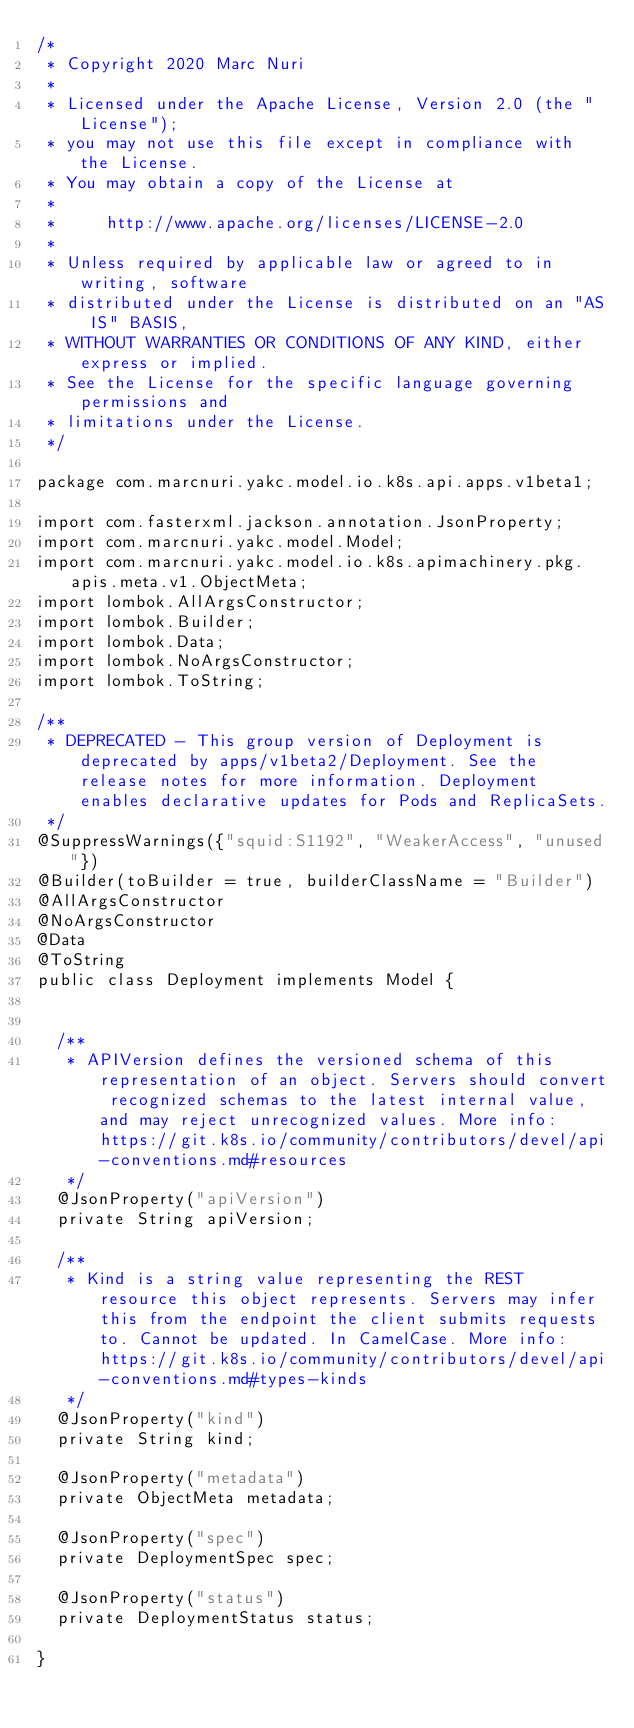Convert code to text. <code><loc_0><loc_0><loc_500><loc_500><_Java_>/*
 * Copyright 2020 Marc Nuri
 *
 * Licensed under the Apache License, Version 2.0 (the "License");
 * you may not use this file except in compliance with the License.
 * You may obtain a copy of the License at
 *
 *     http://www.apache.org/licenses/LICENSE-2.0
 *
 * Unless required by applicable law or agreed to in writing, software
 * distributed under the License is distributed on an "AS IS" BASIS,
 * WITHOUT WARRANTIES OR CONDITIONS OF ANY KIND, either express or implied.
 * See the License for the specific language governing permissions and
 * limitations under the License.
 */

package com.marcnuri.yakc.model.io.k8s.api.apps.v1beta1;

import com.fasterxml.jackson.annotation.JsonProperty;
import com.marcnuri.yakc.model.Model;
import com.marcnuri.yakc.model.io.k8s.apimachinery.pkg.apis.meta.v1.ObjectMeta;
import lombok.AllArgsConstructor;
import lombok.Builder;
import lombok.Data;
import lombok.NoArgsConstructor;
import lombok.ToString;

/**
 * DEPRECATED - This group version of Deployment is deprecated by apps/v1beta2/Deployment. See the release notes for more information. Deployment enables declarative updates for Pods and ReplicaSets.
 */
@SuppressWarnings({"squid:S1192", "WeakerAccess", "unused"})
@Builder(toBuilder = true, builderClassName = "Builder")
@AllArgsConstructor
@NoArgsConstructor
@Data
@ToString
public class Deployment implements Model {


  /**
   * APIVersion defines the versioned schema of this representation of an object. Servers should convert recognized schemas to the latest internal value, and may reject unrecognized values. More info: https://git.k8s.io/community/contributors/devel/api-conventions.md#resources
   */
  @JsonProperty("apiVersion")
  private String apiVersion;

  /**
   * Kind is a string value representing the REST resource this object represents. Servers may infer this from the endpoint the client submits requests to. Cannot be updated. In CamelCase. More info: https://git.k8s.io/community/contributors/devel/api-conventions.md#types-kinds
   */
  @JsonProperty("kind")
  private String kind;

  @JsonProperty("metadata")
  private ObjectMeta metadata;

  @JsonProperty("spec")
  private DeploymentSpec spec;

  @JsonProperty("status")
  private DeploymentStatus status;

}

</code> 